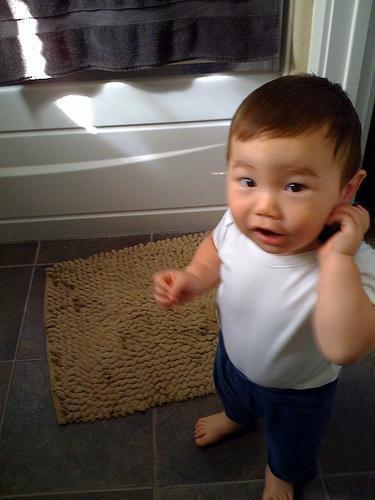How many towels are in the picture?
Give a very brief answer. 1. How many toothbrushes in the photo?
Give a very brief answer. 0. 